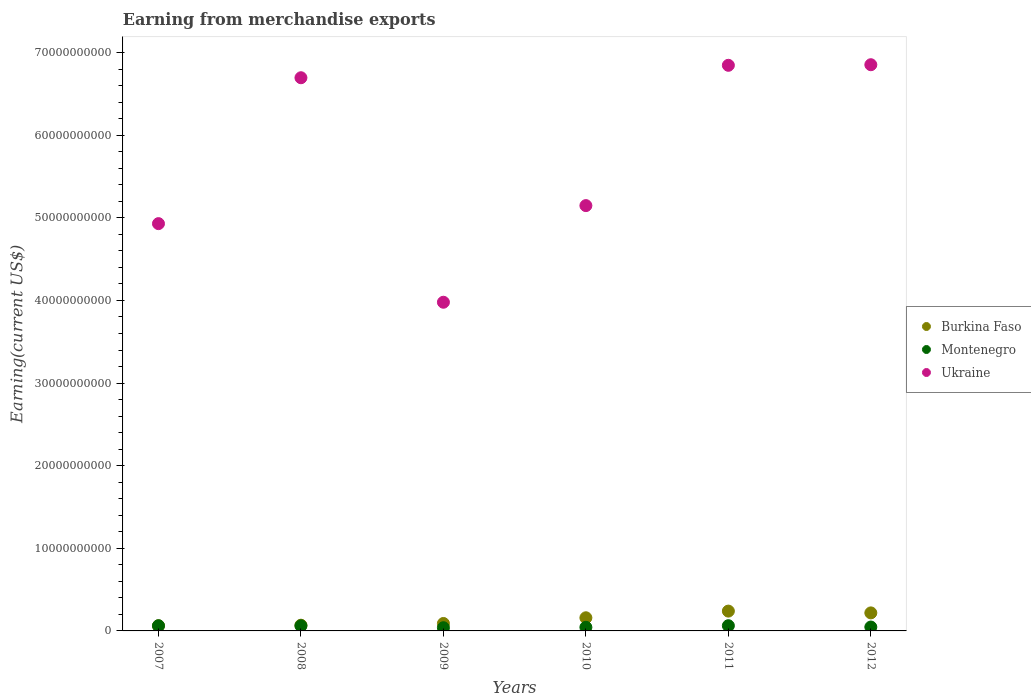How many different coloured dotlines are there?
Your answer should be very brief. 3. Is the number of dotlines equal to the number of legend labels?
Make the answer very short. Yes. What is the amount earned from merchandise exports in Montenegro in 2012?
Provide a succinct answer. 4.72e+08. Across all years, what is the maximum amount earned from merchandise exports in Burkina Faso?
Give a very brief answer. 2.40e+09. Across all years, what is the minimum amount earned from merchandise exports in Montenegro?
Ensure brevity in your answer.  3.88e+08. In which year was the amount earned from merchandise exports in Burkina Faso maximum?
Provide a short and direct response. 2011. In which year was the amount earned from merchandise exports in Ukraine minimum?
Give a very brief answer. 2009. What is the total amount earned from merchandise exports in Burkina Faso in the graph?
Offer a terse response. 8.39e+09. What is the difference between the amount earned from merchandise exports in Ukraine in 2007 and that in 2012?
Provide a succinct answer. -1.92e+1. What is the difference between the amount earned from merchandise exports in Burkina Faso in 2011 and the amount earned from merchandise exports in Ukraine in 2009?
Your answer should be very brief. -3.74e+1. What is the average amount earned from merchandise exports in Burkina Faso per year?
Ensure brevity in your answer.  1.40e+09. In the year 2008, what is the difference between the amount earned from merchandise exports in Ukraine and amount earned from merchandise exports in Burkina Faso?
Make the answer very short. 6.63e+1. In how many years, is the amount earned from merchandise exports in Montenegro greater than 6000000000 US$?
Keep it short and to the point. 0. What is the ratio of the amount earned from merchandise exports in Ukraine in 2010 to that in 2011?
Keep it short and to the point. 0.75. What is the difference between the highest and the second highest amount earned from merchandise exports in Burkina Faso?
Give a very brief answer. 2.17e+08. What is the difference between the highest and the lowest amount earned from merchandise exports in Montenegro?
Give a very brief answer. 2.44e+08. Is the sum of the amount earned from merchandise exports in Burkina Faso in 2008 and 2012 greater than the maximum amount earned from merchandise exports in Montenegro across all years?
Ensure brevity in your answer.  Yes. Does the amount earned from merchandise exports in Burkina Faso monotonically increase over the years?
Your answer should be compact. No. Is the amount earned from merchandise exports in Ukraine strictly greater than the amount earned from merchandise exports in Montenegro over the years?
Your response must be concise. Yes. How many years are there in the graph?
Your answer should be compact. 6. What is the difference between two consecutive major ticks on the Y-axis?
Offer a very short reply. 1.00e+1. Does the graph contain any zero values?
Make the answer very short. No. What is the title of the graph?
Give a very brief answer. Earning from merchandise exports. Does "Low & middle income" appear as one of the legend labels in the graph?
Offer a terse response. No. What is the label or title of the Y-axis?
Ensure brevity in your answer.  Earning(current US$). What is the Earning(current US$) of Burkina Faso in 2007?
Provide a succinct answer. 6.23e+08. What is the Earning(current US$) of Montenegro in 2007?
Offer a terse response. 6.26e+08. What is the Earning(current US$) in Ukraine in 2007?
Make the answer very short. 4.93e+1. What is the Earning(current US$) of Burkina Faso in 2008?
Your answer should be compact. 6.93e+08. What is the Earning(current US$) of Montenegro in 2008?
Make the answer very short. 6.17e+08. What is the Earning(current US$) of Ukraine in 2008?
Your answer should be compact. 6.70e+1. What is the Earning(current US$) in Burkina Faso in 2009?
Your answer should be compact. 9.00e+08. What is the Earning(current US$) in Montenegro in 2009?
Provide a succinct answer. 3.88e+08. What is the Earning(current US$) of Ukraine in 2009?
Provide a succinct answer. 3.98e+1. What is the Earning(current US$) in Burkina Faso in 2010?
Your answer should be compact. 1.59e+09. What is the Earning(current US$) of Montenegro in 2010?
Ensure brevity in your answer.  4.37e+08. What is the Earning(current US$) of Ukraine in 2010?
Provide a succinct answer. 5.15e+1. What is the Earning(current US$) in Burkina Faso in 2011?
Keep it short and to the point. 2.40e+09. What is the Earning(current US$) in Montenegro in 2011?
Provide a succinct answer. 6.32e+08. What is the Earning(current US$) in Ukraine in 2011?
Your answer should be compact. 6.85e+1. What is the Earning(current US$) of Burkina Faso in 2012?
Offer a terse response. 2.18e+09. What is the Earning(current US$) in Montenegro in 2012?
Make the answer very short. 4.72e+08. What is the Earning(current US$) in Ukraine in 2012?
Offer a terse response. 6.85e+1. Across all years, what is the maximum Earning(current US$) in Burkina Faso?
Your answer should be very brief. 2.40e+09. Across all years, what is the maximum Earning(current US$) in Montenegro?
Offer a very short reply. 6.32e+08. Across all years, what is the maximum Earning(current US$) in Ukraine?
Offer a terse response. 6.85e+1. Across all years, what is the minimum Earning(current US$) of Burkina Faso?
Keep it short and to the point. 6.23e+08. Across all years, what is the minimum Earning(current US$) in Montenegro?
Make the answer very short. 3.88e+08. Across all years, what is the minimum Earning(current US$) of Ukraine?
Offer a terse response. 3.98e+1. What is the total Earning(current US$) in Burkina Faso in the graph?
Offer a very short reply. 8.39e+09. What is the total Earning(current US$) of Montenegro in the graph?
Provide a short and direct response. 3.17e+09. What is the total Earning(current US$) of Ukraine in the graph?
Make the answer very short. 3.45e+11. What is the difference between the Earning(current US$) in Burkina Faso in 2007 and that in 2008?
Ensure brevity in your answer.  -7.02e+07. What is the difference between the Earning(current US$) in Montenegro in 2007 and that in 2008?
Your answer should be compact. 9.67e+06. What is the difference between the Earning(current US$) of Ukraine in 2007 and that in 2008?
Give a very brief answer. -1.77e+1. What is the difference between the Earning(current US$) in Burkina Faso in 2007 and that in 2009?
Offer a terse response. -2.77e+08. What is the difference between the Earning(current US$) of Montenegro in 2007 and that in 2009?
Your answer should be compact. 2.39e+08. What is the difference between the Earning(current US$) of Ukraine in 2007 and that in 2009?
Make the answer very short. 9.51e+09. What is the difference between the Earning(current US$) in Burkina Faso in 2007 and that in 2010?
Keep it short and to the point. -9.68e+08. What is the difference between the Earning(current US$) in Montenegro in 2007 and that in 2010?
Your answer should be compact. 1.90e+08. What is the difference between the Earning(current US$) of Ukraine in 2007 and that in 2010?
Make the answer very short. -2.18e+09. What is the difference between the Earning(current US$) of Burkina Faso in 2007 and that in 2011?
Keep it short and to the point. -1.78e+09. What is the difference between the Earning(current US$) in Montenegro in 2007 and that in 2011?
Your response must be concise. -5.50e+06. What is the difference between the Earning(current US$) of Ukraine in 2007 and that in 2011?
Your answer should be very brief. -1.92e+1. What is the difference between the Earning(current US$) of Burkina Faso in 2007 and that in 2012?
Provide a succinct answer. -1.56e+09. What is the difference between the Earning(current US$) in Montenegro in 2007 and that in 2012?
Make the answer very short. 1.55e+08. What is the difference between the Earning(current US$) in Ukraine in 2007 and that in 2012?
Offer a very short reply. -1.92e+1. What is the difference between the Earning(current US$) of Burkina Faso in 2008 and that in 2009?
Offer a terse response. -2.07e+08. What is the difference between the Earning(current US$) in Montenegro in 2008 and that in 2009?
Offer a very short reply. 2.29e+08. What is the difference between the Earning(current US$) in Ukraine in 2008 and that in 2009?
Offer a terse response. 2.72e+1. What is the difference between the Earning(current US$) in Burkina Faso in 2008 and that in 2010?
Provide a succinct answer. -8.98e+08. What is the difference between the Earning(current US$) in Montenegro in 2008 and that in 2010?
Your answer should be very brief. 1.80e+08. What is the difference between the Earning(current US$) of Ukraine in 2008 and that in 2010?
Your answer should be compact. 1.55e+1. What is the difference between the Earning(current US$) of Burkina Faso in 2008 and that in 2011?
Offer a very short reply. -1.71e+09. What is the difference between the Earning(current US$) of Montenegro in 2008 and that in 2011?
Make the answer very short. -1.52e+07. What is the difference between the Earning(current US$) in Ukraine in 2008 and that in 2011?
Keep it short and to the point. -1.51e+09. What is the difference between the Earning(current US$) in Burkina Faso in 2008 and that in 2012?
Make the answer very short. -1.49e+09. What is the difference between the Earning(current US$) of Montenegro in 2008 and that in 2012?
Keep it short and to the point. 1.45e+08. What is the difference between the Earning(current US$) in Ukraine in 2008 and that in 2012?
Provide a succinct answer. -1.58e+09. What is the difference between the Earning(current US$) of Burkina Faso in 2009 and that in 2010?
Offer a very short reply. -6.91e+08. What is the difference between the Earning(current US$) in Montenegro in 2009 and that in 2010?
Your answer should be very brief. -4.90e+07. What is the difference between the Earning(current US$) of Ukraine in 2009 and that in 2010?
Your response must be concise. -1.17e+1. What is the difference between the Earning(current US$) in Burkina Faso in 2009 and that in 2011?
Give a very brief answer. -1.50e+09. What is the difference between the Earning(current US$) in Montenegro in 2009 and that in 2011?
Make the answer very short. -2.44e+08. What is the difference between the Earning(current US$) in Ukraine in 2009 and that in 2011?
Provide a succinct answer. -2.87e+1. What is the difference between the Earning(current US$) of Burkina Faso in 2009 and that in 2012?
Your response must be concise. -1.28e+09. What is the difference between the Earning(current US$) of Montenegro in 2009 and that in 2012?
Your answer should be compact. -8.41e+07. What is the difference between the Earning(current US$) in Ukraine in 2009 and that in 2012?
Your answer should be compact. -2.87e+1. What is the difference between the Earning(current US$) of Burkina Faso in 2010 and that in 2011?
Offer a terse response. -8.08e+08. What is the difference between the Earning(current US$) in Montenegro in 2010 and that in 2011?
Your response must be concise. -1.95e+08. What is the difference between the Earning(current US$) in Ukraine in 2010 and that in 2011?
Your answer should be very brief. -1.70e+1. What is the difference between the Earning(current US$) of Burkina Faso in 2010 and that in 2012?
Provide a succinct answer. -5.91e+08. What is the difference between the Earning(current US$) of Montenegro in 2010 and that in 2012?
Offer a terse response. -3.50e+07. What is the difference between the Earning(current US$) of Ukraine in 2010 and that in 2012?
Offer a very short reply. -1.71e+1. What is the difference between the Earning(current US$) of Burkina Faso in 2011 and that in 2012?
Keep it short and to the point. 2.17e+08. What is the difference between the Earning(current US$) of Montenegro in 2011 and that in 2012?
Ensure brevity in your answer.  1.60e+08. What is the difference between the Earning(current US$) of Ukraine in 2011 and that in 2012?
Offer a very short reply. -7.00e+07. What is the difference between the Earning(current US$) of Burkina Faso in 2007 and the Earning(current US$) of Montenegro in 2008?
Your answer should be compact. 6.38e+06. What is the difference between the Earning(current US$) in Burkina Faso in 2007 and the Earning(current US$) in Ukraine in 2008?
Make the answer very short. -6.63e+1. What is the difference between the Earning(current US$) of Montenegro in 2007 and the Earning(current US$) of Ukraine in 2008?
Give a very brief answer. -6.63e+1. What is the difference between the Earning(current US$) in Burkina Faso in 2007 and the Earning(current US$) in Montenegro in 2009?
Offer a terse response. 2.35e+08. What is the difference between the Earning(current US$) in Burkina Faso in 2007 and the Earning(current US$) in Ukraine in 2009?
Provide a succinct answer. -3.92e+1. What is the difference between the Earning(current US$) of Montenegro in 2007 and the Earning(current US$) of Ukraine in 2009?
Your response must be concise. -3.92e+1. What is the difference between the Earning(current US$) in Burkina Faso in 2007 and the Earning(current US$) in Montenegro in 2010?
Offer a terse response. 1.86e+08. What is the difference between the Earning(current US$) of Burkina Faso in 2007 and the Earning(current US$) of Ukraine in 2010?
Offer a very short reply. -5.09e+1. What is the difference between the Earning(current US$) in Montenegro in 2007 and the Earning(current US$) in Ukraine in 2010?
Make the answer very short. -5.09e+1. What is the difference between the Earning(current US$) in Burkina Faso in 2007 and the Earning(current US$) in Montenegro in 2011?
Make the answer very short. -8.79e+06. What is the difference between the Earning(current US$) in Burkina Faso in 2007 and the Earning(current US$) in Ukraine in 2011?
Your response must be concise. -6.78e+1. What is the difference between the Earning(current US$) of Montenegro in 2007 and the Earning(current US$) of Ukraine in 2011?
Offer a very short reply. -6.78e+1. What is the difference between the Earning(current US$) in Burkina Faso in 2007 and the Earning(current US$) in Montenegro in 2012?
Offer a very short reply. 1.51e+08. What is the difference between the Earning(current US$) of Burkina Faso in 2007 and the Earning(current US$) of Ukraine in 2012?
Offer a terse response. -6.79e+1. What is the difference between the Earning(current US$) of Montenegro in 2007 and the Earning(current US$) of Ukraine in 2012?
Keep it short and to the point. -6.79e+1. What is the difference between the Earning(current US$) in Burkina Faso in 2008 and the Earning(current US$) in Montenegro in 2009?
Your answer should be very brief. 3.06e+08. What is the difference between the Earning(current US$) in Burkina Faso in 2008 and the Earning(current US$) in Ukraine in 2009?
Make the answer very short. -3.91e+1. What is the difference between the Earning(current US$) of Montenegro in 2008 and the Earning(current US$) of Ukraine in 2009?
Provide a succinct answer. -3.92e+1. What is the difference between the Earning(current US$) in Burkina Faso in 2008 and the Earning(current US$) in Montenegro in 2010?
Offer a very short reply. 2.57e+08. What is the difference between the Earning(current US$) of Burkina Faso in 2008 and the Earning(current US$) of Ukraine in 2010?
Provide a succinct answer. -5.08e+1. What is the difference between the Earning(current US$) of Montenegro in 2008 and the Earning(current US$) of Ukraine in 2010?
Give a very brief answer. -5.09e+1. What is the difference between the Earning(current US$) in Burkina Faso in 2008 and the Earning(current US$) in Montenegro in 2011?
Your answer should be very brief. 6.14e+07. What is the difference between the Earning(current US$) in Burkina Faso in 2008 and the Earning(current US$) in Ukraine in 2011?
Offer a very short reply. -6.78e+1. What is the difference between the Earning(current US$) of Montenegro in 2008 and the Earning(current US$) of Ukraine in 2011?
Make the answer very short. -6.78e+1. What is the difference between the Earning(current US$) in Burkina Faso in 2008 and the Earning(current US$) in Montenegro in 2012?
Make the answer very short. 2.22e+08. What is the difference between the Earning(current US$) of Burkina Faso in 2008 and the Earning(current US$) of Ukraine in 2012?
Your response must be concise. -6.78e+1. What is the difference between the Earning(current US$) in Montenegro in 2008 and the Earning(current US$) in Ukraine in 2012?
Offer a terse response. -6.79e+1. What is the difference between the Earning(current US$) in Burkina Faso in 2009 and the Earning(current US$) in Montenegro in 2010?
Keep it short and to the point. 4.64e+08. What is the difference between the Earning(current US$) of Burkina Faso in 2009 and the Earning(current US$) of Ukraine in 2010?
Make the answer very short. -5.06e+1. What is the difference between the Earning(current US$) of Montenegro in 2009 and the Earning(current US$) of Ukraine in 2010?
Offer a terse response. -5.11e+1. What is the difference between the Earning(current US$) in Burkina Faso in 2009 and the Earning(current US$) in Montenegro in 2011?
Provide a short and direct response. 2.69e+08. What is the difference between the Earning(current US$) of Burkina Faso in 2009 and the Earning(current US$) of Ukraine in 2011?
Your response must be concise. -6.76e+1. What is the difference between the Earning(current US$) of Montenegro in 2009 and the Earning(current US$) of Ukraine in 2011?
Offer a very short reply. -6.81e+1. What is the difference between the Earning(current US$) in Burkina Faso in 2009 and the Earning(current US$) in Montenegro in 2012?
Your answer should be very brief. 4.29e+08. What is the difference between the Earning(current US$) in Burkina Faso in 2009 and the Earning(current US$) in Ukraine in 2012?
Give a very brief answer. -6.76e+1. What is the difference between the Earning(current US$) of Montenegro in 2009 and the Earning(current US$) of Ukraine in 2012?
Keep it short and to the point. -6.81e+1. What is the difference between the Earning(current US$) of Burkina Faso in 2010 and the Earning(current US$) of Montenegro in 2011?
Ensure brevity in your answer.  9.59e+08. What is the difference between the Earning(current US$) in Burkina Faso in 2010 and the Earning(current US$) in Ukraine in 2011?
Offer a very short reply. -6.69e+1. What is the difference between the Earning(current US$) in Montenegro in 2010 and the Earning(current US$) in Ukraine in 2011?
Your answer should be very brief. -6.80e+1. What is the difference between the Earning(current US$) in Burkina Faso in 2010 and the Earning(current US$) in Montenegro in 2012?
Your answer should be very brief. 1.12e+09. What is the difference between the Earning(current US$) of Burkina Faso in 2010 and the Earning(current US$) of Ukraine in 2012?
Offer a terse response. -6.69e+1. What is the difference between the Earning(current US$) of Montenegro in 2010 and the Earning(current US$) of Ukraine in 2012?
Provide a short and direct response. -6.81e+1. What is the difference between the Earning(current US$) of Burkina Faso in 2011 and the Earning(current US$) of Montenegro in 2012?
Your response must be concise. 1.93e+09. What is the difference between the Earning(current US$) of Burkina Faso in 2011 and the Earning(current US$) of Ukraine in 2012?
Provide a short and direct response. -6.61e+1. What is the difference between the Earning(current US$) of Montenegro in 2011 and the Earning(current US$) of Ukraine in 2012?
Ensure brevity in your answer.  -6.79e+1. What is the average Earning(current US$) of Burkina Faso per year?
Your response must be concise. 1.40e+09. What is the average Earning(current US$) in Montenegro per year?
Ensure brevity in your answer.  5.28e+08. What is the average Earning(current US$) of Ukraine per year?
Make the answer very short. 5.74e+1. In the year 2007, what is the difference between the Earning(current US$) in Burkina Faso and Earning(current US$) in Montenegro?
Offer a terse response. -3.29e+06. In the year 2007, what is the difference between the Earning(current US$) in Burkina Faso and Earning(current US$) in Ukraine?
Offer a very short reply. -4.87e+1. In the year 2007, what is the difference between the Earning(current US$) in Montenegro and Earning(current US$) in Ukraine?
Your answer should be compact. -4.87e+1. In the year 2008, what is the difference between the Earning(current US$) in Burkina Faso and Earning(current US$) in Montenegro?
Provide a succinct answer. 7.65e+07. In the year 2008, what is the difference between the Earning(current US$) of Burkina Faso and Earning(current US$) of Ukraine?
Make the answer very short. -6.63e+1. In the year 2008, what is the difference between the Earning(current US$) in Montenegro and Earning(current US$) in Ukraine?
Provide a short and direct response. -6.63e+1. In the year 2009, what is the difference between the Earning(current US$) of Burkina Faso and Earning(current US$) of Montenegro?
Give a very brief answer. 5.13e+08. In the year 2009, what is the difference between the Earning(current US$) of Burkina Faso and Earning(current US$) of Ukraine?
Make the answer very short. -3.89e+1. In the year 2009, what is the difference between the Earning(current US$) of Montenegro and Earning(current US$) of Ukraine?
Your response must be concise. -3.94e+1. In the year 2010, what is the difference between the Earning(current US$) in Burkina Faso and Earning(current US$) in Montenegro?
Provide a succinct answer. 1.15e+09. In the year 2010, what is the difference between the Earning(current US$) of Burkina Faso and Earning(current US$) of Ukraine?
Provide a succinct answer. -4.99e+1. In the year 2010, what is the difference between the Earning(current US$) in Montenegro and Earning(current US$) in Ukraine?
Offer a very short reply. -5.10e+1. In the year 2011, what is the difference between the Earning(current US$) in Burkina Faso and Earning(current US$) in Montenegro?
Provide a short and direct response. 1.77e+09. In the year 2011, what is the difference between the Earning(current US$) of Burkina Faso and Earning(current US$) of Ukraine?
Offer a very short reply. -6.61e+1. In the year 2011, what is the difference between the Earning(current US$) in Montenegro and Earning(current US$) in Ukraine?
Offer a very short reply. -6.78e+1. In the year 2012, what is the difference between the Earning(current US$) in Burkina Faso and Earning(current US$) in Montenegro?
Offer a terse response. 1.71e+09. In the year 2012, what is the difference between the Earning(current US$) in Burkina Faso and Earning(current US$) in Ukraine?
Keep it short and to the point. -6.63e+1. In the year 2012, what is the difference between the Earning(current US$) in Montenegro and Earning(current US$) in Ukraine?
Provide a short and direct response. -6.81e+1. What is the ratio of the Earning(current US$) in Burkina Faso in 2007 to that in 2008?
Provide a succinct answer. 0.9. What is the ratio of the Earning(current US$) of Montenegro in 2007 to that in 2008?
Your answer should be very brief. 1.02. What is the ratio of the Earning(current US$) of Ukraine in 2007 to that in 2008?
Give a very brief answer. 0.74. What is the ratio of the Earning(current US$) of Burkina Faso in 2007 to that in 2009?
Offer a very short reply. 0.69. What is the ratio of the Earning(current US$) in Montenegro in 2007 to that in 2009?
Your response must be concise. 1.62. What is the ratio of the Earning(current US$) in Ukraine in 2007 to that in 2009?
Ensure brevity in your answer.  1.24. What is the ratio of the Earning(current US$) of Burkina Faso in 2007 to that in 2010?
Keep it short and to the point. 0.39. What is the ratio of the Earning(current US$) of Montenegro in 2007 to that in 2010?
Ensure brevity in your answer.  1.43. What is the ratio of the Earning(current US$) in Ukraine in 2007 to that in 2010?
Provide a succinct answer. 0.96. What is the ratio of the Earning(current US$) of Burkina Faso in 2007 to that in 2011?
Offer a very short reply. 0.26. What is the ratio of the Earning(current US$) in Montenegro in 2007 to that in 2011?
Your answer should be very brief. 0.99. What is the ratio of the Earning(current US$) of Ukraine in 2007 to that in 2011?
Your answer should be compact. 0.72. What is the ratio of the Earning(current US$) of Burkina Faso in 2007 to that in 2012?
Your response must be concise. 0.29. What is the ratio of the Earning(current US$) in Montenegro in 2007 to that in 2012?
Your response must be concise. 1.33. What is the ratio of the Earning(current US$) of Ukraine in 2007 to that in 2012?
Offer a very short reply. 0.72. What is the ratio of the Earning(current US$) of Burkina Faso in 2008 to that in 2009?
Your response must be concise. 0.77. What is the ratio of the Earning(current US$) in Montenegro in 2008 to that in 2009?
Your response must be concise. 1.59. What is the ratio of the Earning(current US$) of Ukraine in 2008 to that in 2009?
Keep it short and to the point. 1.68. What is the ratio of the Earning(current US$) of Burkina Faso in 2008 to that in 2010?
Offer a terse response. 0.44. What is the ratio of the Earning(current US$) in Montenegro in 2008 to that in 2010?
Ensure brevity in your answer.  1.41. What is the ratio of the Earning(current US$) of Ukraine in 2008 to that in 2010?
Provide a succinct answer. 1.3. What is the ratio of the Earning(current US$) of Burkina Faso in 2008 to that in 2011?
Give a very brief answer. 0.29. What is the ratio of the Earning(current US$) of Burkina Faso in 2008 to that in 2012?
Give a very brief answer. 0.32. What is the ratio of the Earning(current US$) in Montenegro in 2008 to that in 2012?
Your response must be concise. 1.31. What is the ratio of the Earning(current US$) of Burkina Faso in 2009 to that in 2010?
Your response must be concise. 0.57. What is the ratio of the Earning(current US$) in Montenegro in 2009 to that in 2010?
Provide a short and direct response. 0.89. What is the ratio of the Earning(current US$) of Ukraine in 2009 to that in 2010?
Offer a very short reply. 0.77. What is the ratio of the Earning(current US$) in Burkina Faso in 2009 to that in 2011?
Your response must be concise. 0.38. What is the ratio of the Earning(current US$) in Montenegro in 2009 to that in 2011?
Keep it short and to the point. 0.61. What is the ratio of the Earning(current US$) in Ukraine in 2009 to that in 2011?
Your answer should be very brief. 0.58. What is the ratio of the Earning(current US$) of Burkina Faso in 2009 to that in 2012?
Provide a succinct answer. 0.41. What is the ratio of the Earning(current US$) of Montenegro in 2009 to that in 2012?
Provide a succinct answer. 0.82. What is the ratio of the Earning(current US$) in Ukraine in 2009 to that in 2012?
Ensure brevity in your answer.  0.58. What is the ratio of the Earning(current US$) of Burkina Faso in 2010 to that in 2011?
Ensure brevity in your answer.  0.66. What is the ratio of the Earning(current US$) in Montenegro in 2010 to that in 2011?
Your response must be concise. 0.69. What is the ratio of the Earning(current US$) in Ukraine in 2010 to that in 2011?
Your answer should be compact. 0.75. What is the ratio of the Earning(current US$) in Burkina Faso in 2010 to that in 2012?
Give a very brief answer. 0.73. What is the ratio of the Earning(current US$) in Montenegro in 2010 to that in 2012?
Offer a very short reply. 0.93. What is the ratio of the Earning(current US$) in Ukraine in 2010 to that in 2012?
Offer a very short reply. 0.75. What is the ratio of the Earning(current US$) in Burkina Faso in 2011 to that in 2012?
Give a very brief answer. 1.1. What is the ratio of the Earning(current US$) in Montenegro in 2011 to that in 2012?
Your answer should be very brief. 1.34. What is the ratio of the Earning(current US$) in Ukraine in 2011 to that in 2012?
Your answer should be very brief. 1. What is the difference between the highest and the second highest Earning(current US$) of Burkina Faso?
Provide a succinct answer. 2.17e+08. What is the difference between the highest and the second highest Earning(current US$) of Montenegro?
Provide a short and direct response. 5.50e+06. What is the difference between the highest and the second highest Earning(current US$) of Ukraine?
Offer a very short reply. 7.00e+07. What is the difference between the highest and the lowest Earning(current US$) of Burkina Faso?
Offer a very short reply. 1.78e+09. What is the difference between the highest and the lowest Earning(current US$) of Montenegro?
Your response must be concise. 2.44e+08. What is the difference between the highest and the lowest Earning(current US$) in Ukraine?
Your answer should be very brief. 2.87e+1. 